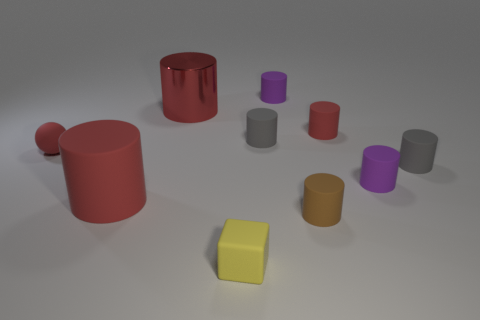Is the number of small purple rubber cylinders that are to the left of the brown matte thing greater than the number of small green cubes?
Keep it short and to the point. Yes. Are there any yellow cubes made of the same material as the tiny ball?
Make the answer very short. Yes. There is a gray matte object in front of the small matte sphere; is its shape the same as the yellow rubber thing?
Your answer should be very brief. No. How many things are in front of the purple matte object behind the red rubber cylinder that is behind the large matte cylinder?
Make the answer very short. 9. Is the number of gray rubber things that are in front of the large red matte object less than the number of purple cylinders in front of the tiny rubber cube?
Make the answer very short. No. There is a large rubber thing that is the same shape as the red metal object; what is its color?
Keep it short and to the point. Red. How big is the shiny cylinder?
Your response must be concise. Large. How many gray rubber things have the same size as the yellow block?
Offer a terse response. 2. Is the color of the small matte ball the same as the small cube?
Give a very brief answer. No. Is the big red cylinder that is on the right side of the large red matte thing made of the same material as the red cylinder on the left side of the large red shiny thing?
Provide a short and direct response. No. 